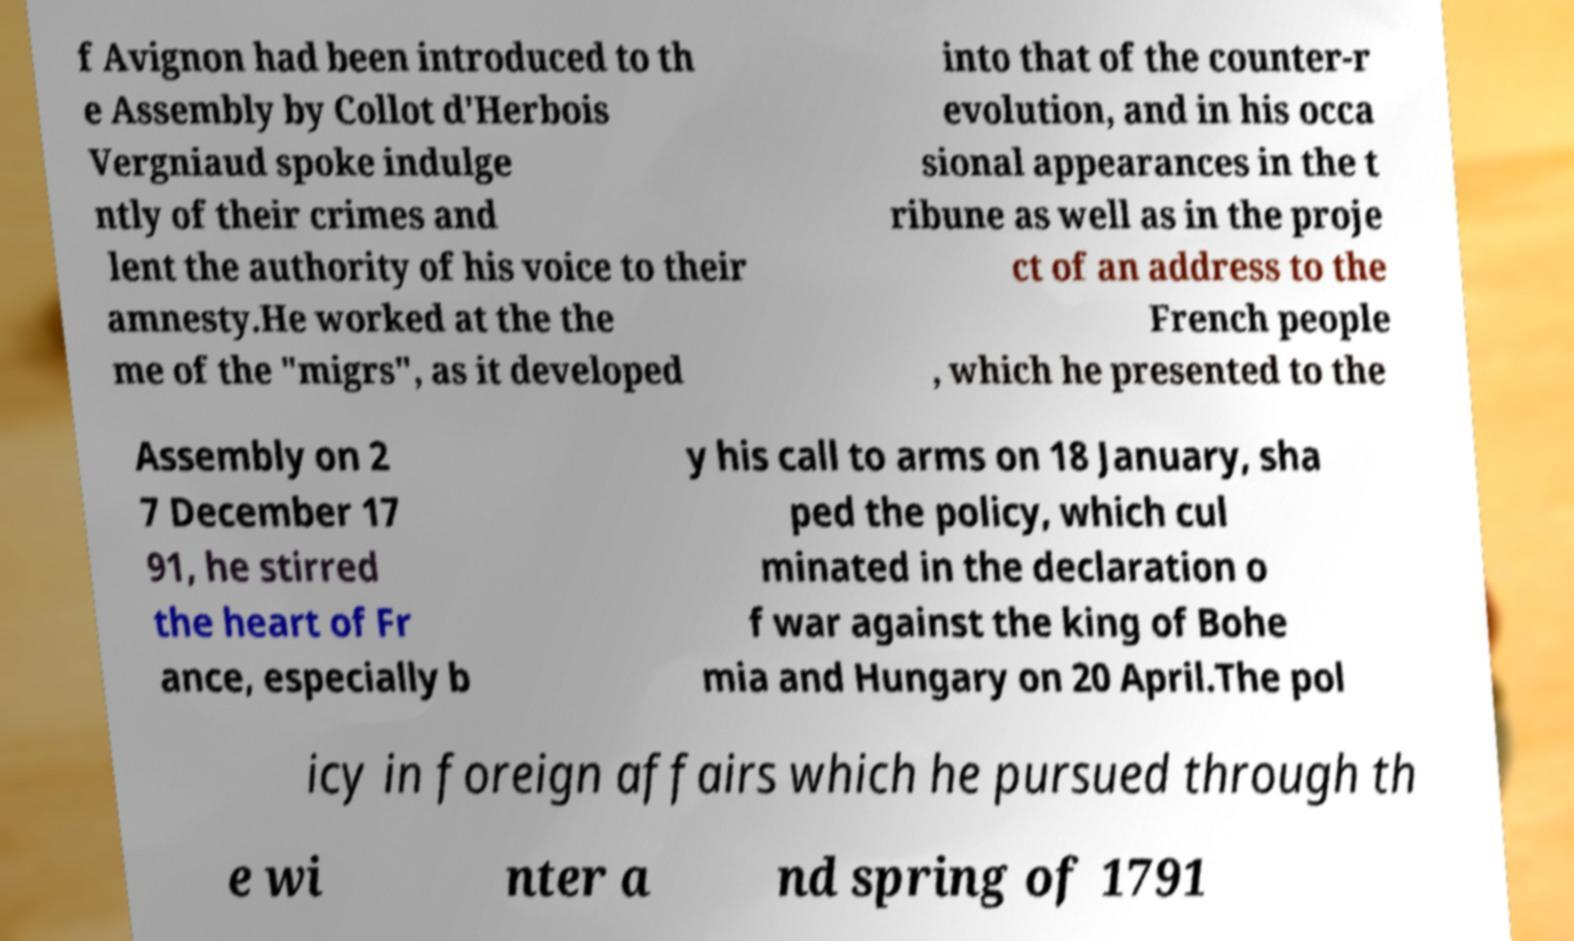For documentation purposes, I need the text within this image transcribed. Could you provide that? f Avignon had been introduced to th e Assembly by Collot d'Herbois Vergniaud spoke indulge ntly of their crimes and lent the authority of his voice to their amnesty.He worked at the the me of the "migrs", as it developed into that of the counter-r evolution, and in his occa sional appearances in the t ribune as well as in the proje ct of an address to the French people , which he presented to the Assembly on 2 7 December 17 91, he stirred the heart of Fr ance, especially b y his call to arms on 18 January, sha ped the policy, which cul minated in the declaration o f war against the king of Bohe mia and Hungary on 20 April.The pol icy in foreign affairs which he pursued through th e wi nter a nd spring of 1791 